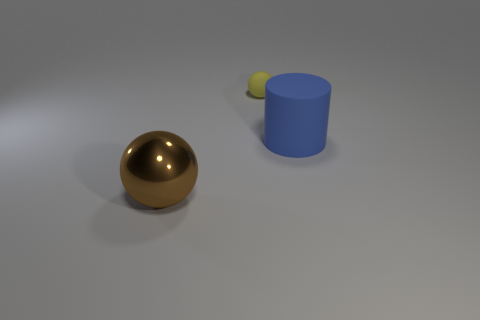Add 2 big objects. How many objects exist? 5 Subtract all spheres. How many objects are left? 1 Add 2 tiny yellow objects. How many tiny yellow objects are left? 3 Add 1 gray cubes. How many gray cubes exist? 1 Subtract 0 yellow blocks. How many objects are left? 3 Subtract all tiny yellow matte spheres. Subtract all brown shiny spheres. How many objects are left? 1 